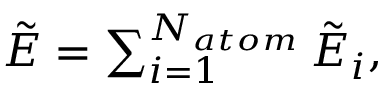<formula> <loc_0><loc_0><loc_500><loc_500>\begin{array} { r } { \tilde { E } = \sum _ { i = 1 } ^ { N _ { a t o m } } \tilde { E } _ { i } , } \end{array}</formula> 